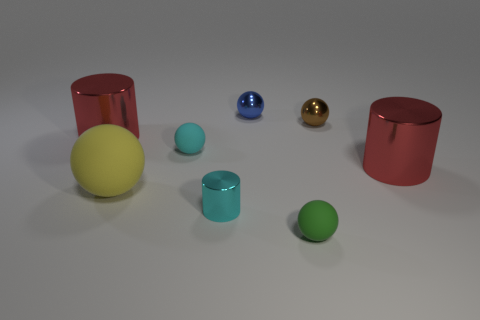There is a sphere that is the same color as the small metallic cylinder; what is it made of?
Make the answer very short. Rubber. Are there fewer red cylinders to the right of the brown thing than large metallic things that are behind the yellow thing?
Ensure brevity in your answer.  Yes. Do the green ball and the brown sphere have the same material?
Make the answer very short. No. There is a object that is both right of the big matte sphere and to the left of the tiny shiny cylinder; what size is it?
Your response must be concise. Small. The blue metal object that is the same size as the brown object is what shape?
Give a very brief answer. Sphere. There is a large thing that is in front of the large red metal cylinder to the right of the large object behind the tiny cyan sphere; what is it made of?
Ensure brevity in your answer.  Rubber. Does the tiny cyan object in front of the big rubber sphere have the same shape as the large metallic object right of the green matte sphere?
Your response must be concise. Yes. What number of other things are made of the same material as the small blue ball?
Your answer should be compact. 4. Are the big red thing that is to the left of the small blue object and the tiny ball in front of the large rubber object made of the same material?
Your answer should be compact. No. What shape is the yellow object that is the same material as the tiny green sphere?
Provide a short and direct response. Sphere. 